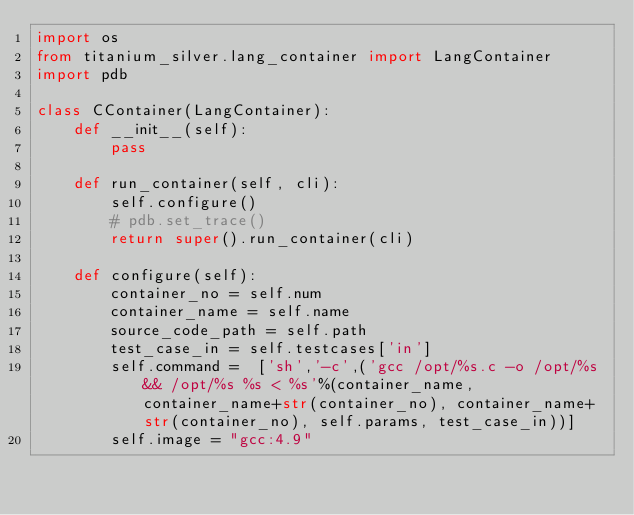Convert code to text. <code><loc_0><loc_0><loc_500><loc_500><_Python_>import os
from titanium_silver.lang_container import LangContainer 
import pdb

class CContainer(LangContainer):
    def __init__(self):
        pass

    def run_container(self, cli):
        self.configure()
        # pdb.set_trace()
        return super().run_container(cli)

    def configure(self):
        container_no = self.num
        container_name = self.name
        source_code_path = self.path
        test_case_in = self.testcases['in']
        self.command =  ['sh','-c',('gcc /opt/%s.c -o /opt/%s && /opt/%s %s < %s'%(container_name, container_name+str(container_no), container_name+str(container_no), self.params, test_case_in))]	 
        self.image = "gcc:4.9"
</code> 